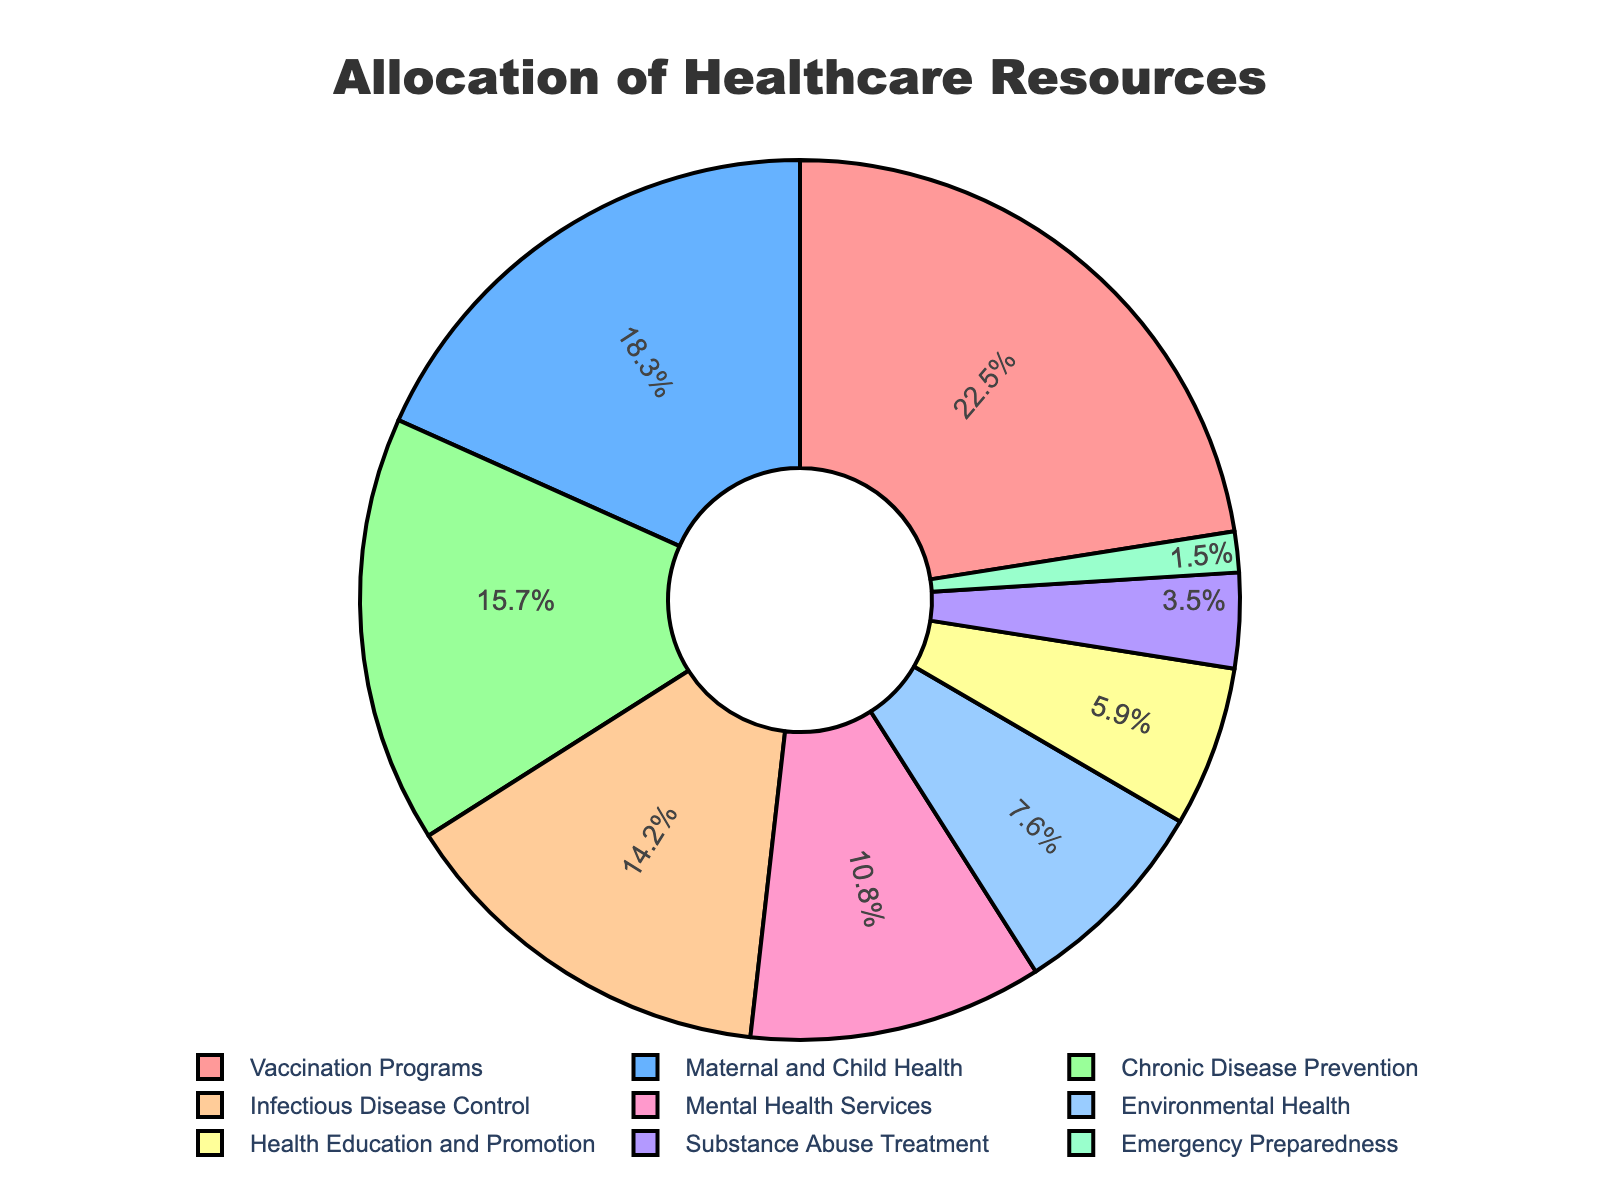How much higher is the percentage allocated to Vaccination Programs compared to Environmental Health? First, identify the percentage for Vaccination Programs (22.5%) and Environmental Health (7.6%). Subtract the percentage of Environmental Health from Vaccination Programs: 22.5% - 7.6% = 14.9%.
Answer: 14.9% Which program has the smallest allocation, and what is its percentage? Inspect the pie chart to find the smallest segment. The smallest allocation is for Emergency Preparedness at 1.5%.
Answer: Emergency Preparedness, 1.5% What percentage of the total budget is spent on programs related to disease (Infectious Disease Control and Chronic Disease Prevention combined)? Locate the percentages for Infectious Disease Control (14.2%) and Chronic Disease Prevention (15.7%) and sum them: 14.2% + 15.7% = 29.9%.
Answer: 29.9% How does the allocation for Health Education and Promotion compare to Substance Abuse Treatment? Identify the percentages for Health Education and Promotion (5.9%) and Substance Abuse Treatment (3.5%). Health Education and Promotion has a higher percentage: 5.9% > 3.5%.
Answer: Health Education and Promotion > Substance Abuse Treatment If we combine Maternal and Child Health with Mental Health Services, what is the new total percentage? Identify the percentages for Maternal and Child Health (18.3%) and Mental Health Services (10.8%). Sum the percentages: 18.3% + 10.8% = 29.1%.
Answer: 29.1% What is the difference in allocation percentage between the highest and second highest programs? Identify the highest (Vaccination Programs, 22.5%) and the second highest (Maternal and Child Health, 18.3%). Subtract the second highest from the highest: 22.5% - 18.3% = 4.2%.
Answer: 4.2% List the programs in descending order of their allocation percentages. Inspect the pie chart and list the programs in descending order: Vaccination Programs (22.5%), Maternal and Child Health (18.3%), Chronic Disease Prevention (15.7%), Infectious Disease Control (14.2%), Mental Health Services (10.8%), Environmental Health (7.6%), Health Education and Promotion (5.9%), Substance Abuse Treatment (3.5%), Emergency Preparedness (1.5%).
Answer: Vaccination Programs, Maternal and Child Health, Chronic Disease Prevention, Infectious Disease Control, Mental Health Services, Environmental Health, Health Education and Promotion, Substance Abuse Treatment, Emergency Preparedness What is the combined percentage for programs allocated less than 10% each? Identify the programs allocated less than 10%: Mental Health Services (10.8%), Environmental Health (7.6%), Health Education and Promotion (5.9%), Substance Abuse Treatment (3.5%), Emergency Preparedness (1.5%). Sum these percentages: 7.6% + 5.9% + 3.5% + 1.5% = 18.5%.
Answer: 18.5% Which program segment in the pie chart is represented with a red color? Observe the pie chart and identify the red-colored segment; it corresponds to Vaccination Programs.
Answer: Vaccination Programs 